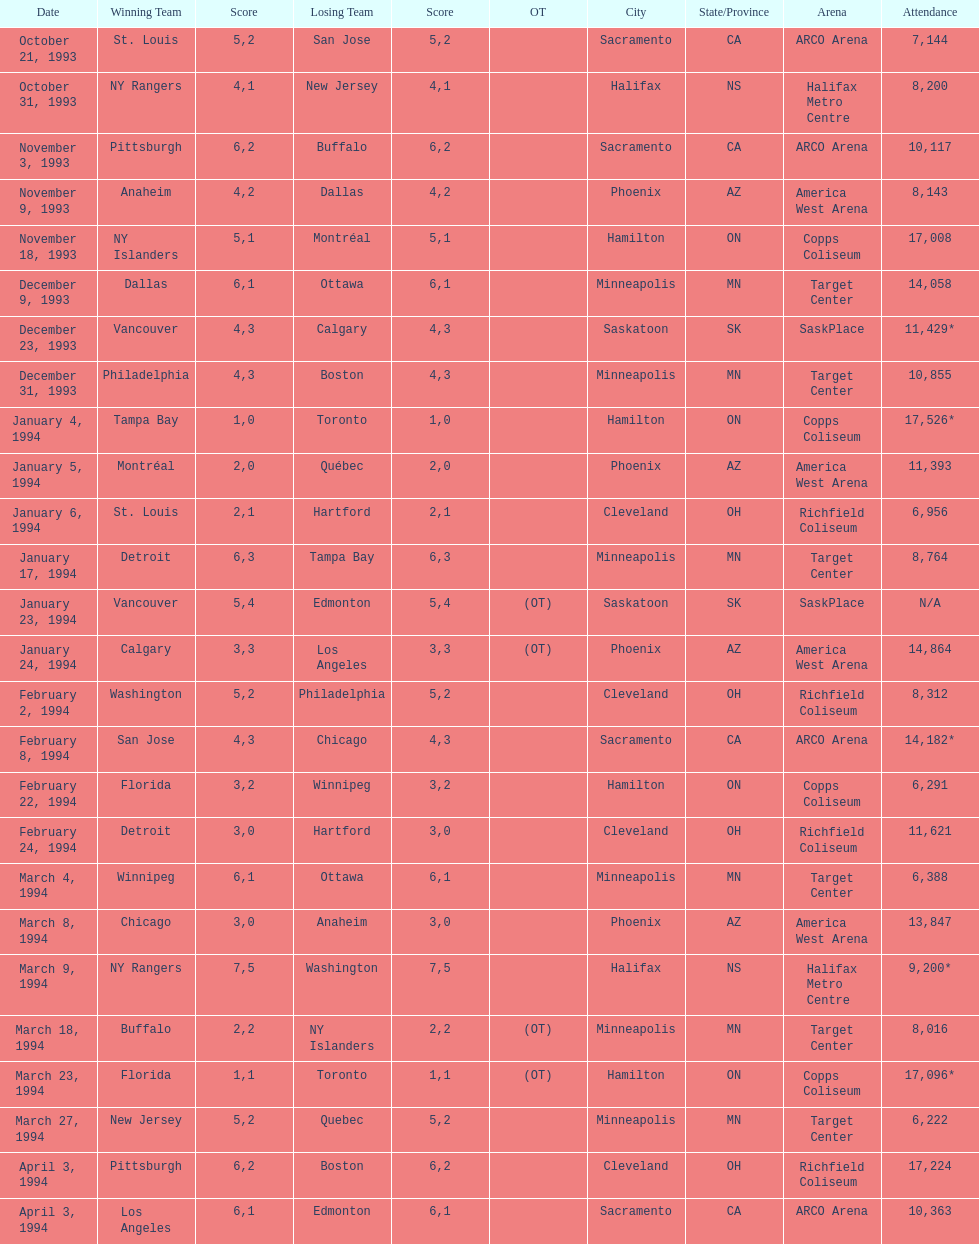Who won the game the day before the january 5, 1994 game? Tampa Bay. 